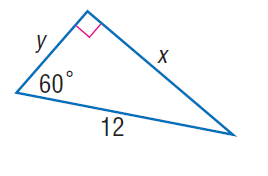Answer the mathemtical geometry problem and directly provide the correct option letter.
Question: Find x.
Choices: A: 2 \sqrt { 3 } B: 3 \sqrt { 3 } C: 5 \sqrt { 3 } D: 6 \sqrt { 3 } D 